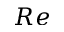Convert formula to latex. <formula><loc_0><loc_0><loc_500><loc_500>R e</formula> 